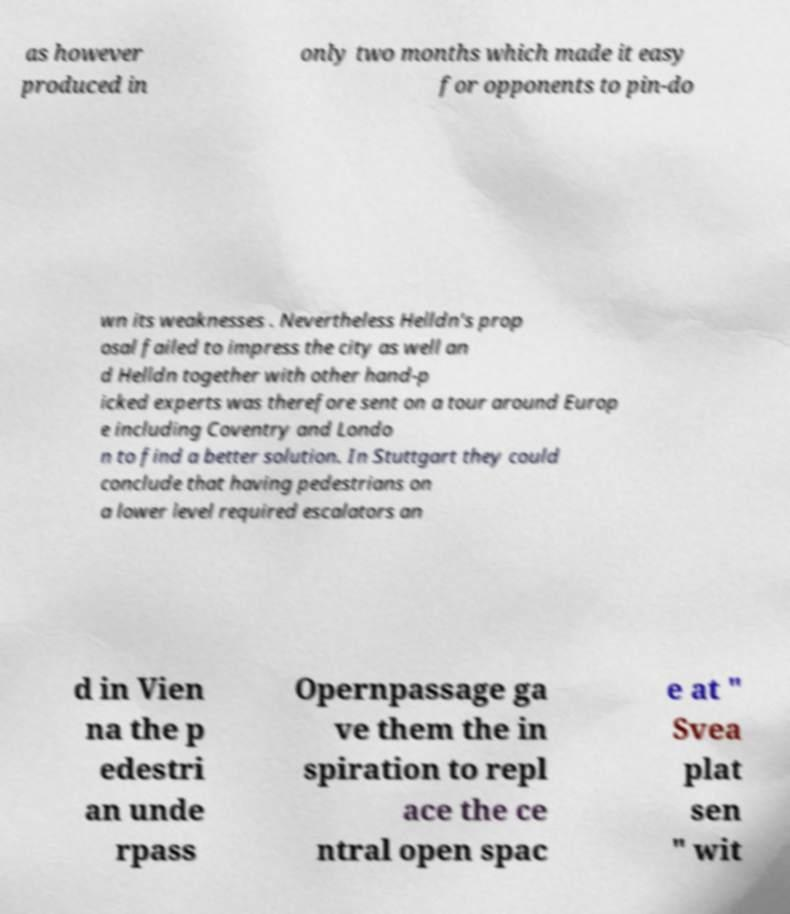Please identify and transcribe the text found in this image. as however produced in only two months which made it easy for opponents to pin-do wn its weaknesses . Nevertheless Helldn's prop osal failed to impress the city as well an d Helldn together with other hand-p icked experts was therefore sent on a tour around Europ e including Coventry and Londo n to find a better solution. In Stuttgart they could conclude that having pedestrians on a lower level required escalators an d in Vien na the p edestri an unde rpass Opernpassage ga ve them the in spiration to repl ace the ce ntral open spac e at " Svea plat sen " wit 